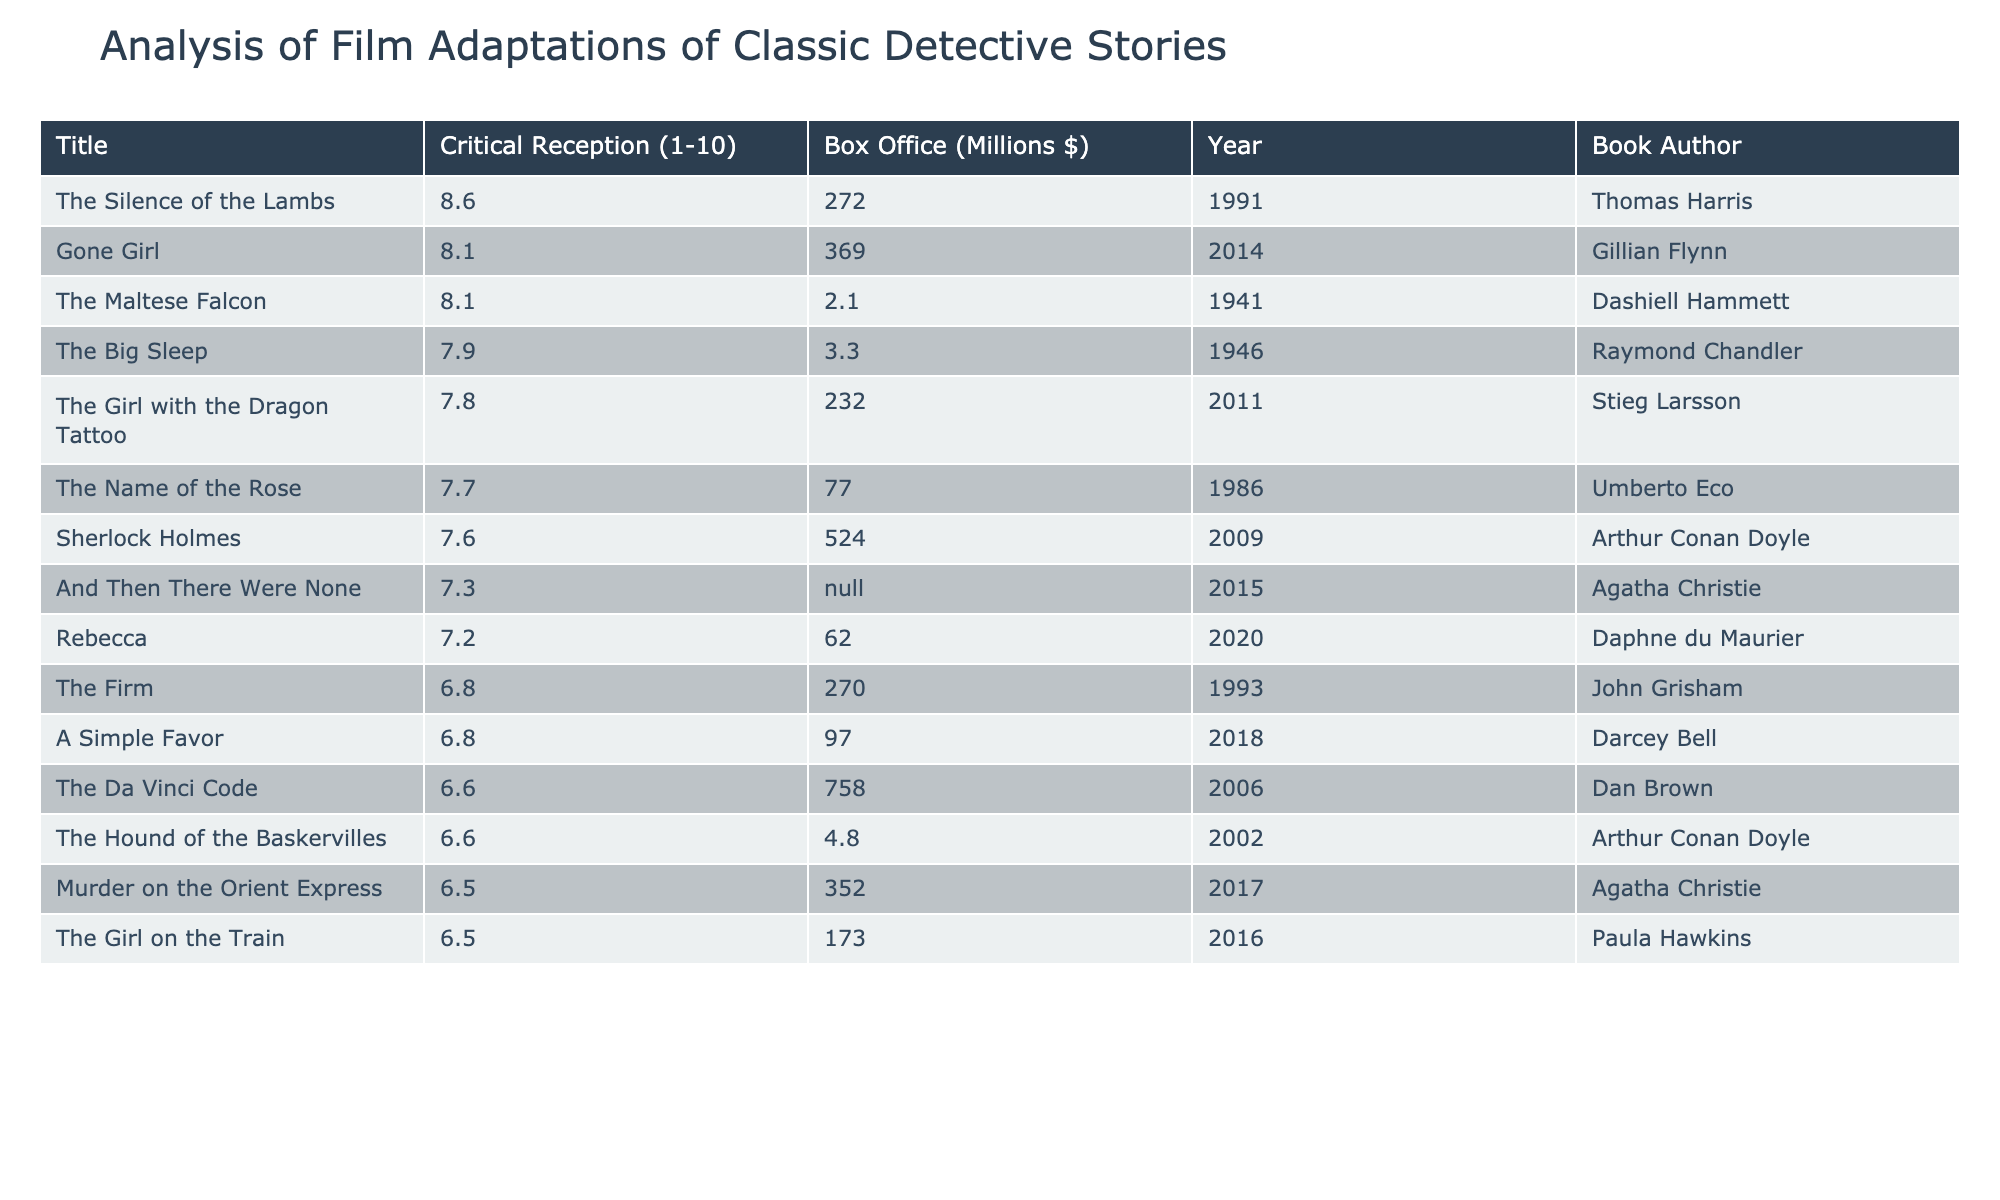What is the title of the film adaptation with the highest critical reception? The critical reception scores are sorted in descending order in the table. The highest score is 8.6, which is associated with "The Silence of the Lambs."
Answer: The Silence of the Lambs Which film adaptation had the lowest box office performance? The box office performance can be found in the relevant column, and the lowest value listed is 2.1 million dollars for "The Maltese Falcon."
Answer: The Maltese Falcon What is the average critical reception score of the films based on the data provided? To calculate the average, sum all the critical reception scores (7.6 + 6.5 + 7.8 + 8.1 + 6.6 + 8.1 + 7.2 + 7.7 + 6.6 + 7.3 + 7.9 + 8.6 + 6.8 + 6.8 + 6.5) = 109.4. Dividing by the number of films (15), we get an average score of approximately 7.29.
Answer: 7.29 Is there a film adaptation of a classic detective story that earned more than 500 million dollars at the box office? Checking the box office column, the only film that earned more than 500 million dollars is "The Da Vinci Code," which made 758 million dollars.
Answer: Yes Which author has the highest average score for their film adaptations? Calculate the average critical reception for each author by summing their film ratings and dividing by the number of adaptations. For example, Arthur Conan Doyle has two adaptations: (7.6 + 6.6) / 2 = 7.1. After calculating for all authors, Agatha Christie has an average of (6.5 + 7.3) / 2 = 6.9, whereas Gillian Flynn has an average of 8.1 (one film). The highest average is 8.6 for Thomas Harris (one film).
Answer: Thomas Harris How many adaptations based on Agatha Christie's work were produced within the last decade? The table shows two adaptations of Agatha Christie's works: "Murder on the Orient Express" (2017) and "And Then There Were None" (2015), both of which fall within the last ten years, giving us a total of 2 adaptations.
Answer: 2 Does the film "Gone Girl" have a higher critical reception than the film "The Girl with the Dragon Tattoo"? Comparing the critical reception scores in the table, "Gone Girl" has a score of 8.1 and "The Girl with the Dragon Tattoo" has a score of 7.8, indicating that "Gone Girl" does indeed have a higher score.
Answer: Yes Which film has the second highest box office earnings, and who is its author? The table shows the box office figures, and "The Da Vinci Code" has the highest at 758 million dollars. The second highest is "Sherlock Holmes" with 524 million dollars, based on this analysis. The author of "Sherlock Holmes" is Arthur Conan Doyle.
Answer: Sherlock Holmes, Arthur Conan Doyle 